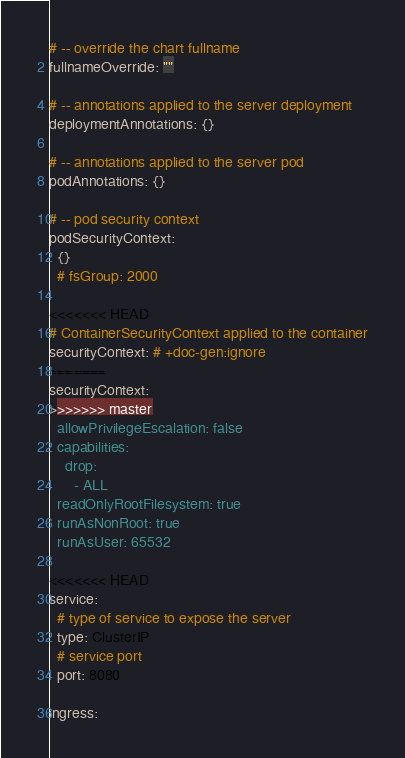Convert code to text. <code><loc_0><loc_0><loc_500><loc_500><_YAML_>
# -- override the chart fullname
fullnameOverride: ""

# -- annotations applied to the server deployment
deploymentAnnotations: {}

# -- annotations applied to the server pod
podAnnotations: {}

# -- pod security context
podSecurityContext:
  {}
  # fsGroup: 2000

<<<<<<< HEAD
# ContainerSecurityContext applied to the container
securityContext: # +doc-gen:ignore
=======
securityContext:
>>>>>>> master
  allowPrivilegeEscalation: false
  capabilities:
    drop:
      - ALL
  readOnlyRootFilesystem: true
  runAsNonRoot: true
  runAsUser: 65532

<<<<<<< HEAD
service:
  # type of service to expose the server
  type: ClusterIP
  # service port
  port: 8080

ingress:</code> 